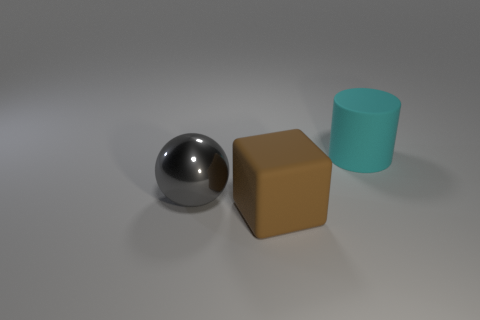Add 3 cylinders. How many objects exist? 6 Subtract all cubes. How many objects are left? 2 Add 3 big gray balls. How many big gray balls are left? 4 Add 2 large cyan matte cylinders. How many large cyan matte cylinders exist? 3 Subtract 0 purple cylinders. How many objects are left? 3 Subtract all gray objects. Subtract all small brown metal objects. How many objects are left? 2 